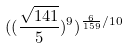Convert formula to latex. <formula><loc_0><loc_0><loc_500><loc_500>( ( \frac { \sqrt { 1 4 1 } } { 5 } ) ^ { 9 } ) ^ { \frac { 6 } { 1 5 9 } / 1 0 }</formula> 